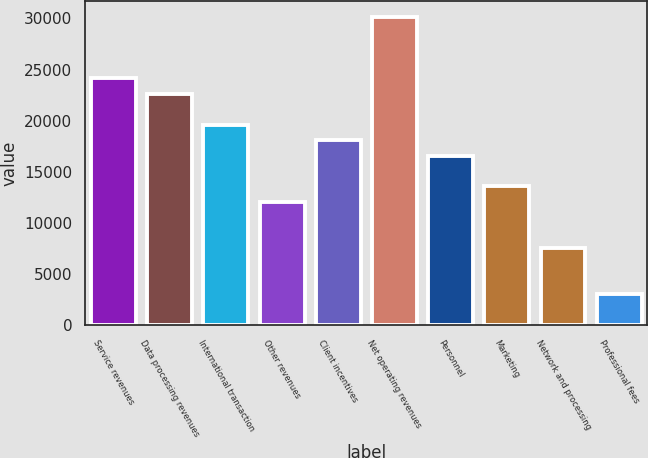<chart> <loc_0><loc_0><loc_500><loc_500><bar_chart><fcel>Service revenues<fcel>Data processing revenues<fcel>International transaction<fcel>Other revenues<fcel>Client incentives<fcel>Net operating revenues<fcel>Personnel<fcel>Marketing<fcel>Network and processing<fcel>Professional fees<nl><fcel>24130<fcel>22622<fcel>19606<fcel>12066<fcel>18098<fcel>30162<fcel>16590<fcel>13574<fcel>7542<fcel>3018<nl></chart> 